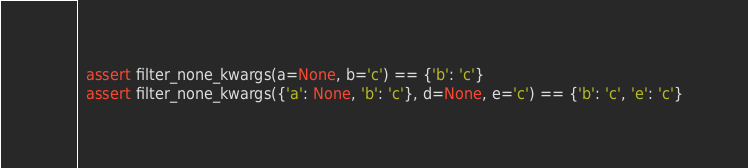Convert code to text. <code><loc_0><loc_0><loc_500><loc_500><_Python_>  assert filter_none_kwargs(a=None, b='c') == {'b': 'c'}
  assert filter_none_kwargs({'a': None, 'b': 'c'}, d=None, e='c') == {'b': 'c', 'e': 'c'}
</code> 